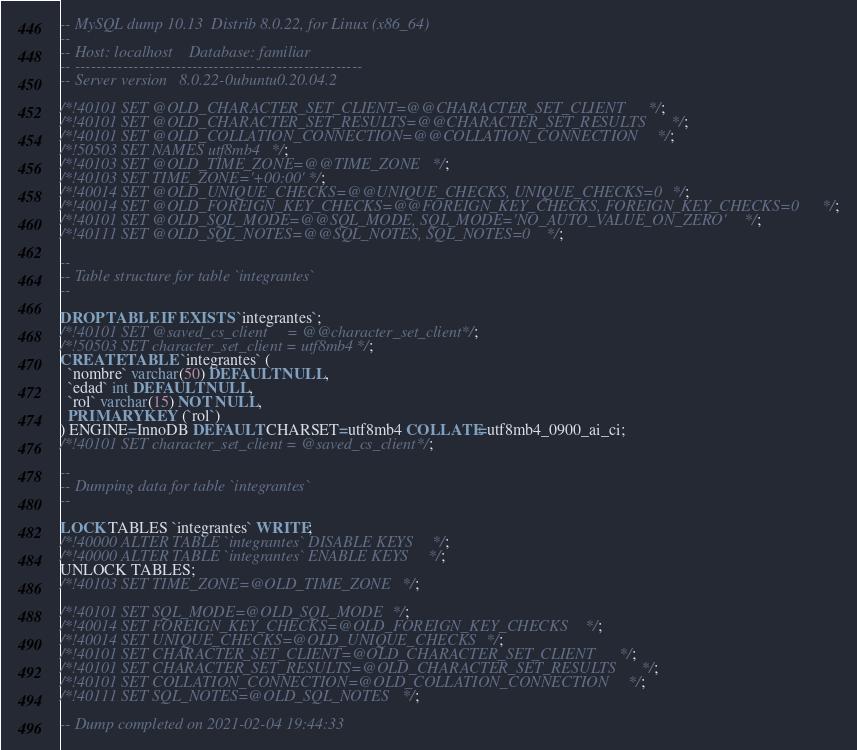Convert code to text. <code><loc_0><loc_0><loc_500><loc_500><_SQL_>-- MySQL dump 10.13  Distrib 8.0.22, for Linux (x86_64)
--
-- Host: localhost    Database: familiar
-- ------------------------------------------------------
-- Server version	8.0.22-0ubuntu0.20.04.2

/*!40101 SET @OLD_CHARACTER_SET_CLIENT=@@CHARACTER_SET_CLIENT */;
/*!40101 SET @OLD_CHARACTER_SET_RESULTS=@@CHARACTER_SET_RESULTS */;
/*!40101 SET @OLD_COLLATION_CONNECTION=@@COLLATION_CONNECTION */;
/*!50503 SET NAMES utf8mb4 */;
/*!40103 SET @OLD_TIME_ZONE=@@TIME_ZONE */;
/*!40103 SET TIME_ZONE='+00:00' */;
/*!40014 SET @OLD_UNIQUE_CHECKS=@@UNIQUE_CHECKS, UNIQUE_CHECKS=0 */;
/*!40014 SET @OLD_FOREIGN_KEY_CHECKS=@@FOREIGN_KEY_CHECKS, FOREIGN_KEY_CHECKS=0 */;
/*!40101 SET @OLD_SQL_MODE=@@SQL_MODE, SQL_MODE='NO_AUTO_VALUE_ON_ZERO' */;
/*!40111 SET @OLD_SQL_NOTES=@@SQL_NOTES, SQL_NOTES=0 */;

--
-- Table structure for table `integrantes`
--

DROP TABLE IF EXISTS `integrantes`;
/*!40101 SET @saved_cs_client     = @@character_set_client */;
/*!50503 SET character_set_client = utf8mb4 */;
CREATE TABLE `integrantes` (
  `nombre` varchar(50) DEFAULT NULL,
  `edad` int DEFAULT NULL,
  `rol` varchar(15) NOT NULL,
  PRIMARY KEY (`rol`)
) ENGINE=InnoDB DEFAULT CHARSET=utf8mb4 COLLATE=utf8mb4_0900_ai_ci;
/*!40101 SET character_set_client = @saved_cs_client */;

--
-- Dumping data for table `integrantes`
--

LOCK TABLES `integrantes` WRITE;
/*!40000 ALTER TABLE `integrantes` DISABLE KEYS */;
/*!40000 ALTER TABLE `integrantes` ENABLE KEYS */;
UNLOCK TABLES;
/*!40103 SET TIME_ZONE=@OLD_TIME_ZONE */;

/*!40101 SET SQL_MODE=@OLD_SQL_MODE */;
/*!40014 SET FOREIGN_KEY_CHECKS=@OLD_FOREIGN_KEY_CHECKS */;
/*!40014 SET UNIQUE_CHECKS=@OLD_UNIQUE_CHECKS */;
/*!40101 SET CHARACTER_SET_CLIENT=@OLD_CHARACTER_SET_CLIENT */;
/*!40101 SET CHARACTER_SET_RESULTS=@OLD_CHARACTER_SET_RESULTS */;
/*!40101 SET COLLATION_CONNECTION=@OLD_COLLATION_CONNECTION */;
/*!40111 SET SQL_NOTES=@OLD_SQL_NOTES */;

-- Dump completed on 2021-02-04 19:44:33
</code> 